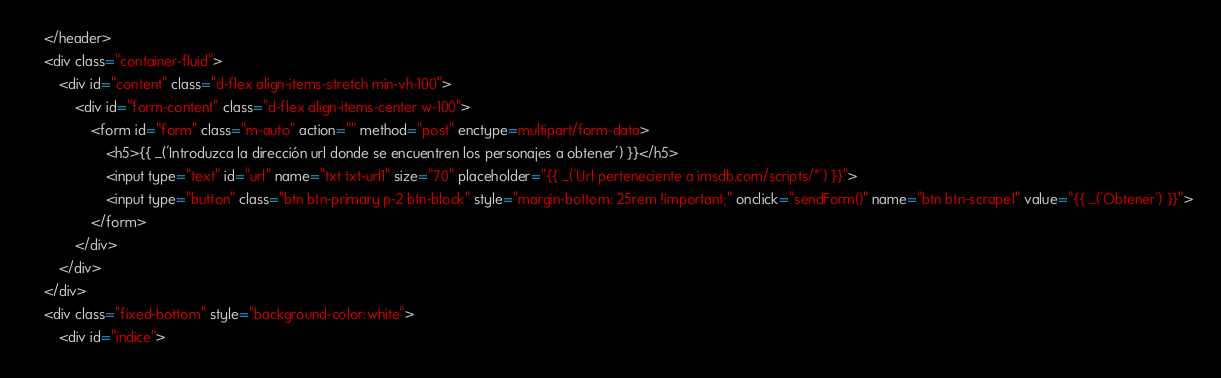<code> <loc_0><loc_0><loc_500><loc_500><_HTML_>	</header>
	<div class="container-fluid">
		<div id="content" class="d-flex align-items-stretch min-vh-100">
			<div id="form-content" class="d-flex align-items-center w-100">
				<form id="form" class="m-auto" action="" method="post" enctype=multipart/form-data>
					<h5>{{ _('Introduzca la dirección url donde se encuentren los personajes a obtener') }}</h5>
					<input type="text" id="url" name="txt txt-url1" size="70" placeholder="{{ _('Url perteneciente a imsdb.com/scripts/*') }}">
					<input type="button" class="btn btn-primary p-2 btn-block" style="margin-bottom: 25rem !important;" onclick="sendForm()" name="btn btn-scrape1" value="{{ _('Obtener') }}">
				</form>
			</div>
		</div>
	</div>
	<div class="fixed-bottom" style="background-color:white">
		<div id="indice"></code> 